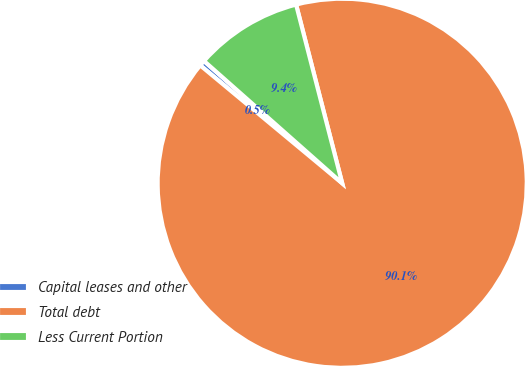Convert chart to OTSL. <chart><loc_0><loc_0><loc_500><loc_500><pie_chart><fcel>Capital leases and other<fcel>Total debt<fcel>Less Current Portion<nl><fcel>0.5%<fcel>90.05%<fcel>9.45%<nl></chart> 